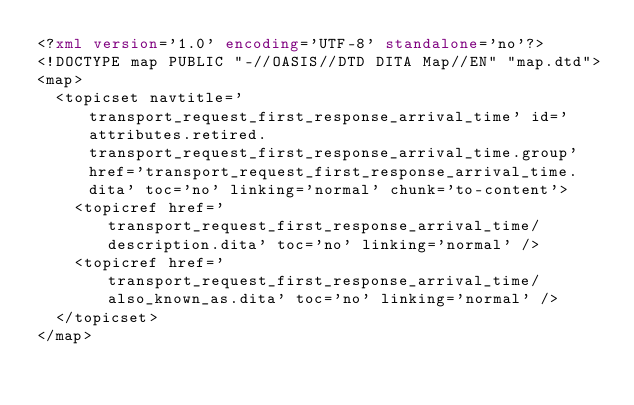<code> <loc_0><loc_0><loc_500><loc_500><_XML_><?xml version='1.0' encoding='UTF-8' standalone='no'?>
<!DOCTYPE map PUBLIC "-//OASIS//DTD DITA Map//EN" "map.dtd">
<map>
  <topicset navtitle='transport_request_first_response_arrival_time' id='attributes.retired.transport_request_first_response_arrival_time.group' href='transport_request_first_response_arrival_time.dita' toc='no' linking='normal' chunk='to-content'>
    <topicref href='transport_request_first_response_arrival_time/description.dita' toc='no' linking='normal' />
    <topicref href='transport_request_first_response_arrival_time/also_known_as.dita' toc='no' linking='normal' />
  </topicset>
</map></code> 